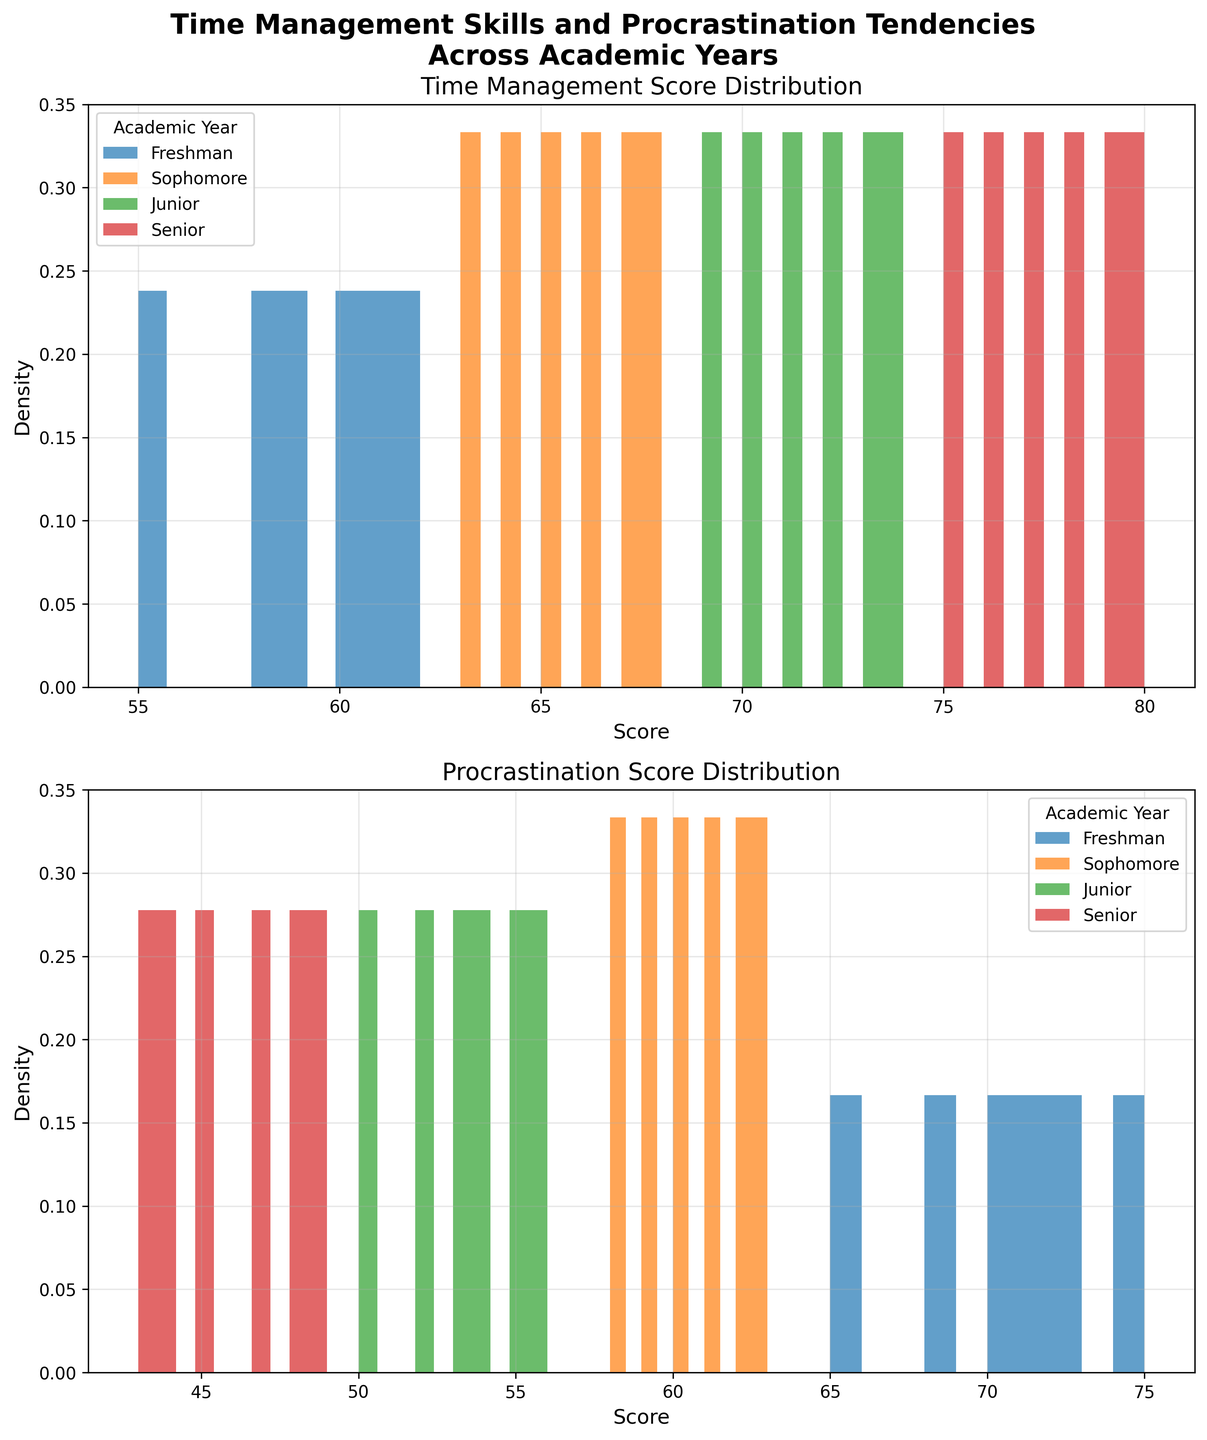What are the titles of the two subplots? There are two subplots in the figure, and their titles can be found at the top of each plotting area. The first subplot's title is located directly above it, and the second subplot's title is above the second plotting area.
Answer: "Time Management Score Distribution" and "Procrastination Score Distribution" Which academic year has the highest density in the 'Time Management Score' histogram? Look for the peak density in the 'Time Management Score' subplot. The peak density can be visually identified by finding the highest point on the curve.
Answer: Senior How do the procrastination tendencies of Freshmen compare to those of Seniors? Compare the peaks and spread of the 'Procrastination Score' histograms for Freshmen and Seniors. The Freshmen's scores are higher (toward the right) and more spread out, whereas the Seniors' scores are lower (toward the left) and more concentrated.
Answer: Freshmen have higher and more spread-out procrastination scores, while Seniors have lower and more concentrated scores Which academic year has the most consistent (least spread out) 'Time Management Score'? Analyze the width of the histograms. The year with the narrowest, highest peak will have the most consistent scores.
Answer: Senior Is there a noticeable trend in 'Time Management Score' from Freshman to Senior year? Observe the shifts in peak densities from left to right in the 'Time Management Score' subplot. Each year's peak should progressively shift to higher values as you move from Freshmen to Seniors.
Answer: Yes, the scores generally increase from Freshman to Senior year What is the approximate range of 'Procrastination Scores' for Sophomores? Check the horizontal axis of the 'Procrastination Score' subplot for Sophomores and identify the span of values covered by their histogram.
Answer: 58 to 62 How do the densities of 'Time Management Scores' for Sophomores and Juniors compare? Look at the heights and shapes of the 'Time Management Score' histograms for Sophomores and Juniors. Juniors tend to have higher peaks and are shifted slightly to the right compared to Sophomores.
Answer: Juniors have higher peaks and slightly higher scores Which academic year shows the greatest density in the lower range for 'Procrastination Scores'? Look at the lower end of the 'Procrastination Score' subplot. Identify which year has the highest peak toward the left.
Answer: Senior 